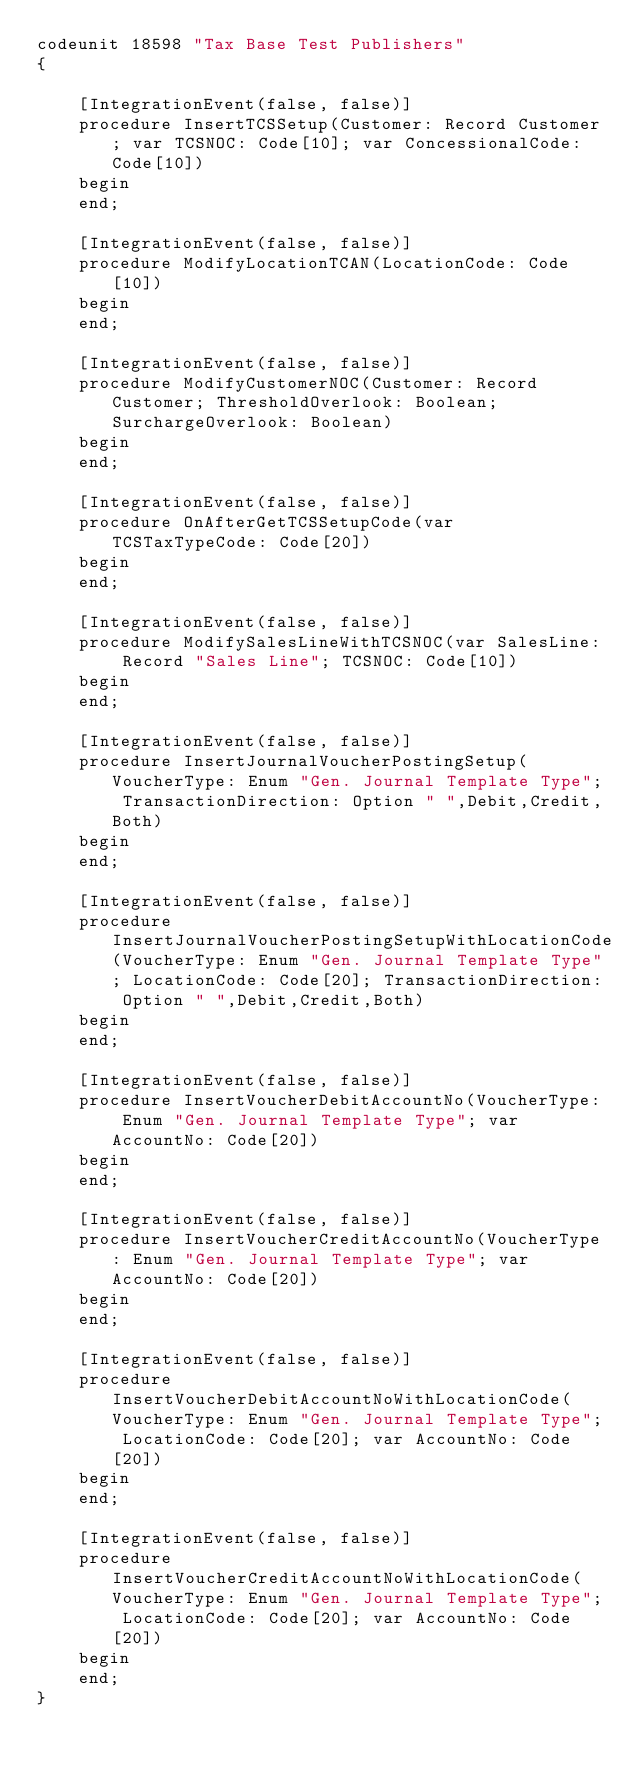Convert code to text. <code><loc_0><loc_0><loc_500><loc_500><_Perl_>codeunit 18598 "Tax Base Test Publishers"
{

    [IntegrationEvent(false, false)]
    procedure InsertTCSSetup(Customer: Record Customer; var TCSNOC: Code[10]; var ConcessionalCode: Code[10])
    begin
    end;

    [IntegrationEvent(false, false)]
    procedure ModifyLocationTCAN(LocationCode: Code[10])
    begin
    end;

    [IntegrationEvent(false, false)]
    procedure ModifyCustomerNOC(Customer: Record Customer; ThresholdOverlook: Boolean; SurchargeOverlook: Boolean)
    begin
    end;

    [IntegrationEvent(false, false)]
    procedure OnAfterGetTCSSetupCode(var TCSTaxTypeCode: Code[20])
    begin
    end;

    [IntegrationEvent(false, false)]
    procedure ModifySalesLineWithTCSNOC(var SalesLine: Record "Sales Line"; TCSNOC: Code[10])
    begin
    end;

    [IntegrationEvent(false, false)]
    procedure InsertJournalVoucherPostingSetup(VoucherType: Enum "Gen. Journal Template Type"; TransactionDirection: Option " ",Debit,Credit,Both)
    begin
    end;

    [IntegrationEvent(false, false)]
    procedure InsertJournalVoucherPostingSetupWithLocationCode(VoucherType: Enum "Gen. Journal Template Type"; LocationCode: Code[20]; TransactionDirection: Option " ",Debit,Credit,Both)
    begin
    end;

    [IntegrationEvent(false, false)]
    procedure InsertVoucherDebitAccountNo(VoucherType: Enum "Gen. Journal Template Type"; var AccountNo: Code[20])
    begin
    end;

    [IntegrationEvent(false, false)]
    procedure InsertVoucherCreditAccountNo(VoucherType: Enum "Gen. Journal Template Type"; var AccountNo: Code[20])
    begin
    end;

    [IntegrationEvent(false, false)]
    procedure InsertVoucherDebitAccountNoWithLocationCode(VoucherType: Enum "Gen. Journal Template Type"; LocationCode: Code[20]; var AccountNo: Code[20])
    begin
    end;

    [IntegrationEvent(false, false)]
    procedure InsertVoucherCreditAccountNoWithLocationCode(VoucherType: Enum "Gen. Journal Template Type"; LocationCode: Code[20]; var AccountNo: Code[20])
    begin
    end;
}</code> 